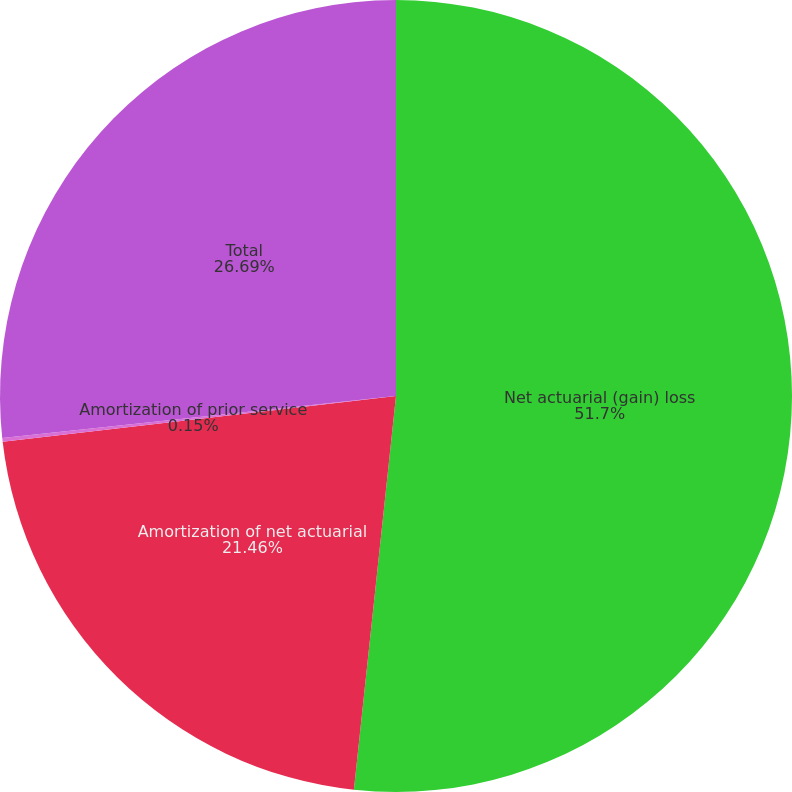<chart> <loc_0><loc_0><loc_500><loc_500><pie_chart><fcel>Net actuarial (gain) loss<fcel>Amortization of net actuarial<fcel>Amortization of prior service<fcel>Total<nl><fcel>51.69%<fcel>21.46%<fcel>0.15%<fcel>26.69%<nl></chart> 